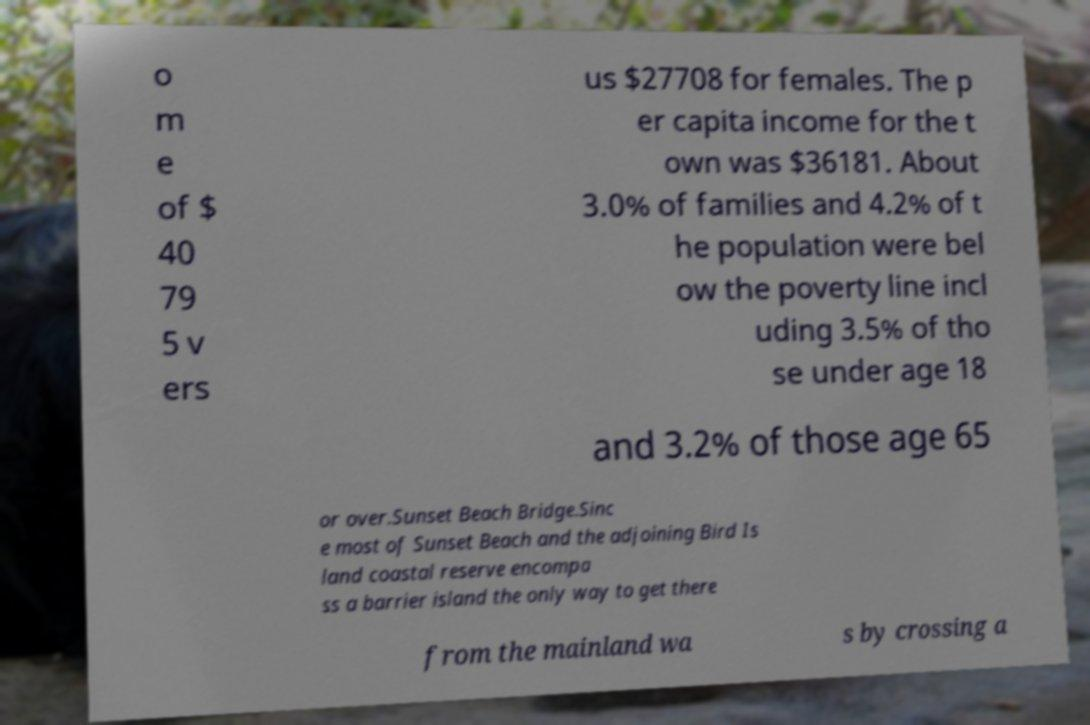I need the written content from this picture converted into text. Can you do that? o m e of $ 40 79 5 v ers us $27708 for females. The p er capita income for the t own was $36181. About 3.0% of families and 4.2% of t he population were bel ow the poverty line incl uding 3.5% of tho se under age 18 and 3.2% of those age 65 or over.Sunset Beach Bridge.Sinc e most of Sunset Beach and the adjoining Bird Is land coastal reserve encompa ss a barrier island the only way to get there from the mainland wa s by crossing a 